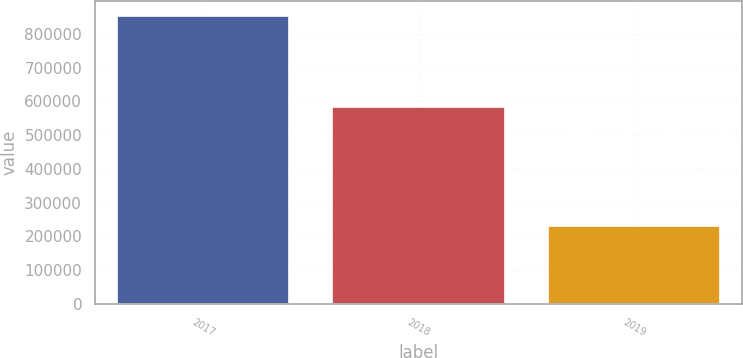<chart> <loc_0><loc_0><loc_500><loc_500><bar_chart><fcel>2017<fcel>2018<fcel>2019<nl><fcel>854000<fcel>583000<fcel>231000<nl></chart> 